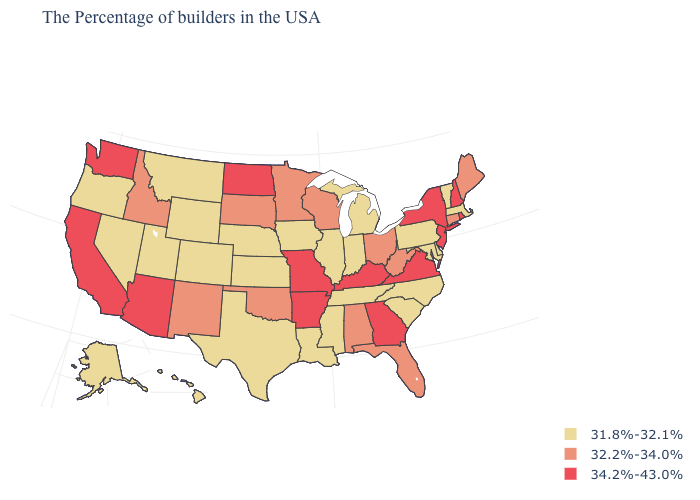Name the states that have a value in the range 34.2%-43.0%?
Write a very short answer. Rhode Island, New Hampshire, New York, New Jersey, Virginia, Georgia, Kentucky, Missouri, Arkansas, North Dakota, Arizona, California, Washington. Does New York have the same value as California?
Give a very brief answer. Yes. Which states have the lowest value in the USA?
Quick response, please. Massachusetts, Vermont, Delaware, Maryland, Pennsylvania, North Carolina, South Carolina, Michigan, Indiana, Tennessee, Illinois, Mississippi, Louisiana, Iowa, Kansas, Nebraska, Texas, Wyoming, Colorado, Utah, Montana, Nevada, Oregon, Alaska, Hawaii. Which states have the lowest value in the USA?
Be succinct. Massachusetts, Vermont, Delaware, Maryland, Pennsylvania, North Carolina, South Carolina, Michigan, Indiana, Tennessee, Illinois, Mississippi, Louisiana, Iowa, Kansas, Nebraska, Texas, Wyoming, Colorado, Utah, Montana, Nevada, Oregon, Alaska, Hawaii. Among the states that border Illinois , does Iowa have the highest value?
Keep it brief. No. Which states have the lowest value in the USA?
Write a very short answer. Massachusetts, Vermont, Delaware, Maryland, Pennsylvania, North Carolina, South Carolina, Michigan, Indiana, Tennessee, Illinois, Mississippi, Louisiana, Iowa, Kansas, Nebraska, Texas, Wyoming, Colorado, Utah, Montana, Nevada, Oregon, Alaska, Hawaii. Which states have the lowest value in the South?
Keep it brief. Delaware, Maryland, North Carolina, South Carolina, Tennessee, Mississippi, Louisiana, Texas. Among the states that border Arizona , which have the highest value?
Give a very brief answer. California. Does South Carolina have the lowest value in the South?
Be succinct. Yes. What is the value of Illinois?
Quick response, please. 31.8%-32.1%. Name the states that have a value in the range 31.8%-32.1%?
Give a very brief answer. Massachusetts, Vermont, Delaware, Maryland, Pennsylvania, North Carolina, South Carolina, Michigan, Indiana, Tennessee, Illinois, Mississippi, Louisiana, Iowa, Kansas, Nebraska, Texas, Wyoming, Colorado, Utah, Montana, Nevada, Oregon, Alaska, Hawaii. Among the states that border Montana , does Wyoming have the lowest value?
Short answer required. Yes. What is the highest value in the USA?
Be succinct. 34.2%-43.0%. Name the states that have a value in the range 31.8%-32.1%?
Write a very short answer. Massachusetts, Vermont, Delaware, Maryland, Pennsylvania, North Carolina, South Carolina, Michigan, Indiana, Tennessee, Illinois, Mississippi, Louisiana, Iowa, Kansas, Nebraska, Texas, Wyoming, Colorado, Utah, Montana, Nevada, Oregon, Alaska, Hawaii. What is the highest value in states that border Idaho?
Concise answer only. 34.2%-43.0%. 